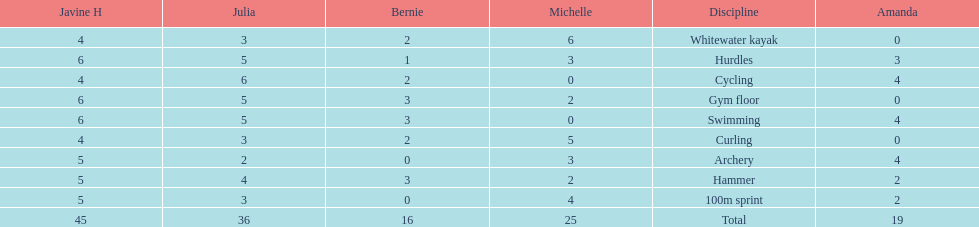What are the number of points bernie scored in hurdles? 1. 